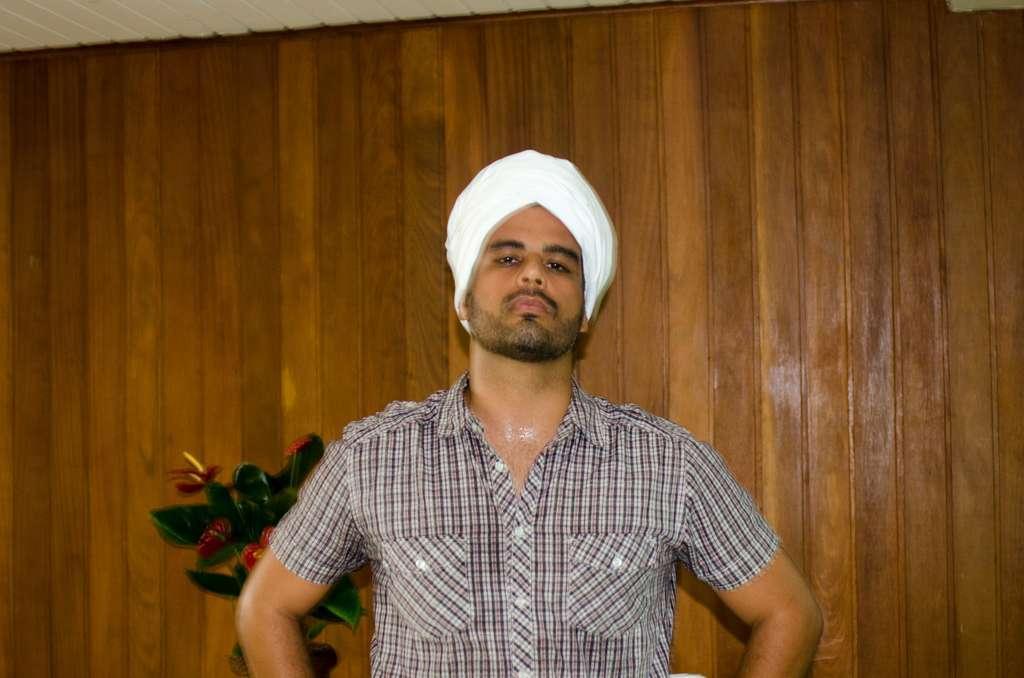How would you summarize this image in a sentence or two? In this picture I can see a man with a turban, there is a flower vase, and in the background there is a wooden wall. 